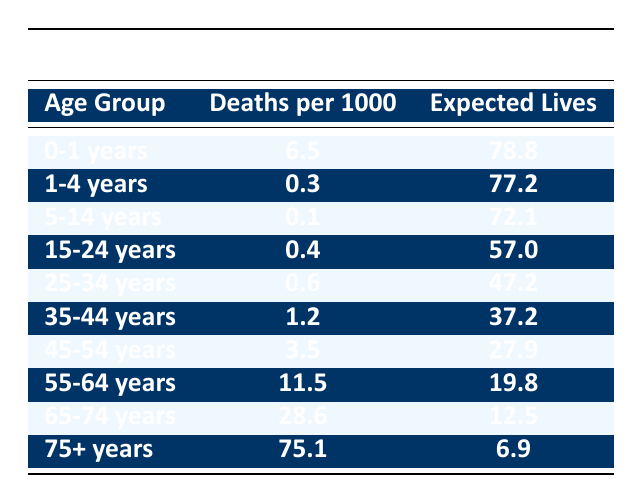What is the death rate for the age group 0-1 years? The table indicates that the deaths per 1000 for the age group 0-1 years is 6.5. This value is directly cited from the "Deaths per 1000" column.
Answer: 6.5 Which age group has the highest expected lives remaining? Looking through the "Expected Lives" column, the highest value is 78.8, which corresponds to the age group 0-1 years. This means infants in this group can expect to live the longest on average.
Answer: 0-1 years What is the average number of deaths per 1000 for the age groups 55-64 years and 65-74 years? The respective deaths per 1000 for these two age groups are 11.5 and 28.6. To find the average, you add these values (11.5 + 28.6 = 40.1) and divide by the number of groups (2), yielding an average of 20.05.
Answer: 20.05 Is the expected life span for individuals aged 75+ years higher than that of individuals aged 15-24 years? The table shows that the expected life span for the age group 75+ years is 6.9 years, while for the age group 15-24 years, it is significantly higher at 57.0 years. Therefore, the statement is false.
Answer: No What is the difference in deaths per 1000 between age groups 45-54 years and 55-64 years? For the age group 45-54 years, the deaths per 1000 is 3.5, and for 55-64 years, it is 11.5. The difference is calculated by subtracting 3.5 from 11.5, which results in 8.0.
Answer: 8.0 Which age group experiences a mortality rate lower than 1 death per 1000? In the table, the age groups 1-4 years, 5-14 years, and 15-24 years all have mortality rates lower than 1 death per 1000, specifically 0.3, 0.1, and 0.4, respectively.
Answer: 1-4 years, 5-14 years, 15-24 years What is the total expected life span remaining for someone aged 35-44 years and someone aged 75+ years? The expected lives remaining for 35-44 years is 37.2 and for 75+ years is 6.9. Adding these values gives a total expected life span remaining of 44.1 years (37.2 + 6.9).
Answer: 44.1 Is it true that the age group 25-34 years has a lower mortality rate than the age group 35-44 years? The mortality rate for 25-34 years is 0.6 deaths per 1000, and for 35-44 years, it is 1.2 deaths per 1000. Since 0.6 is less than 1.2, the statement is true.
Answer: Yes What age group shows a sharp increase in mortality rates based on the table? Analyzing the mortality rates, there is a noticeable increase from the age group 55-64 years (11.5) to 65-74 years (28.6), and even more dramatically to 75+ years (75.1). This indicates a sharp rise in mortality rates as age increases from 55 to 74 and further to 75 years.
Answer: 55-64 years to 65-74 years and 65-74 years to 75+ years 